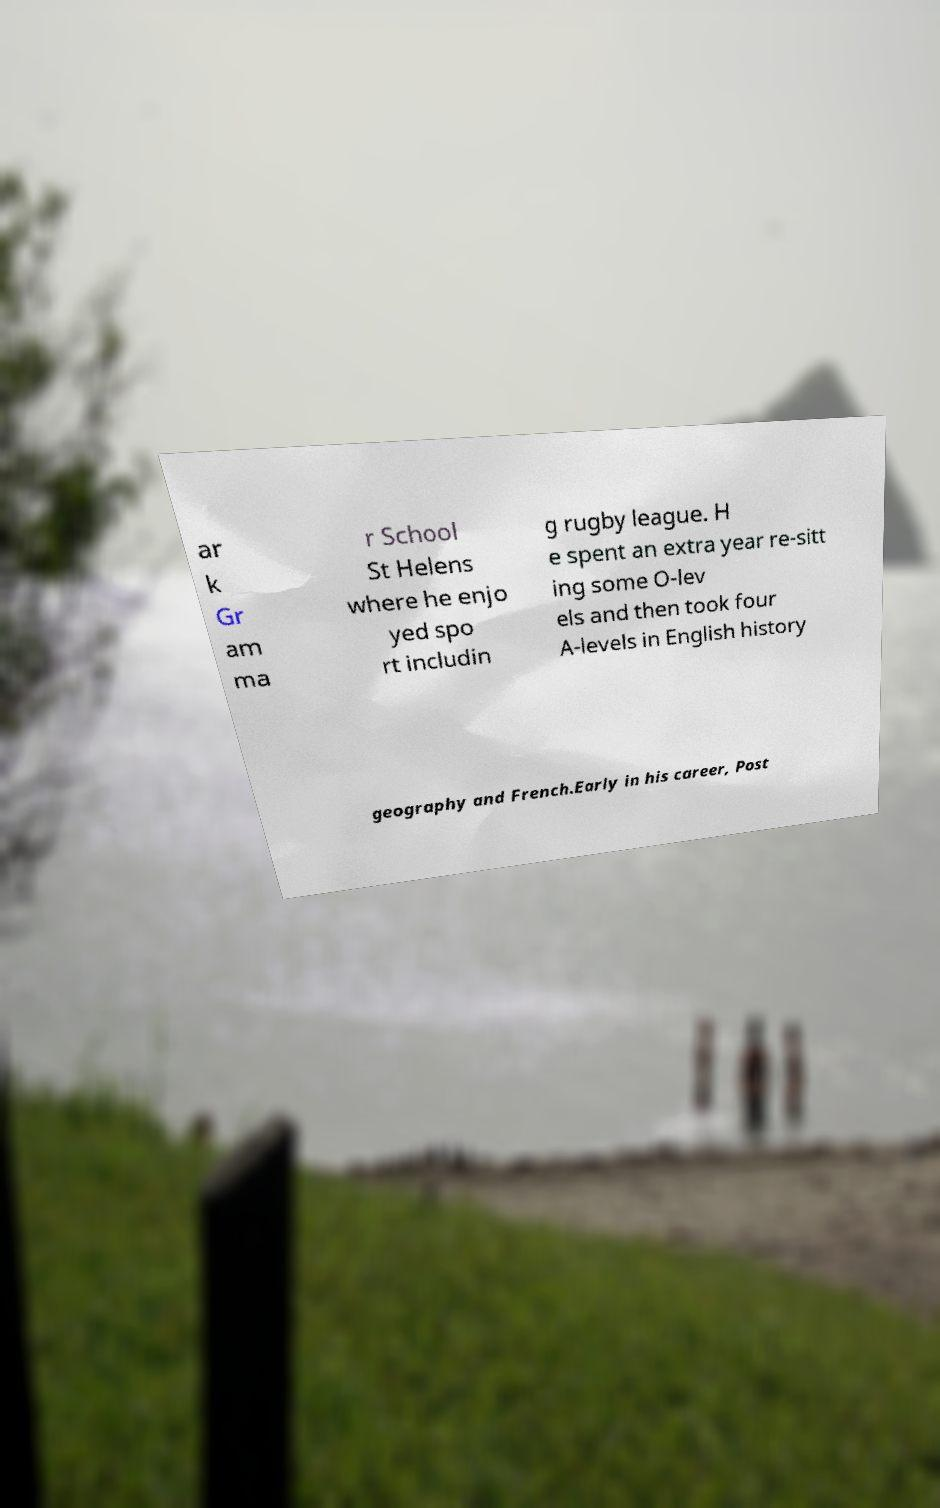Please identify and transcribe the text found in this image. ar k Gr am ma r School St Helens where he enjo yed spo rt includin g rugby league. H e spent an extra year re-sitt ing some O-lev els and then took four A-levels in English history geography and French.Early in his career, Post 